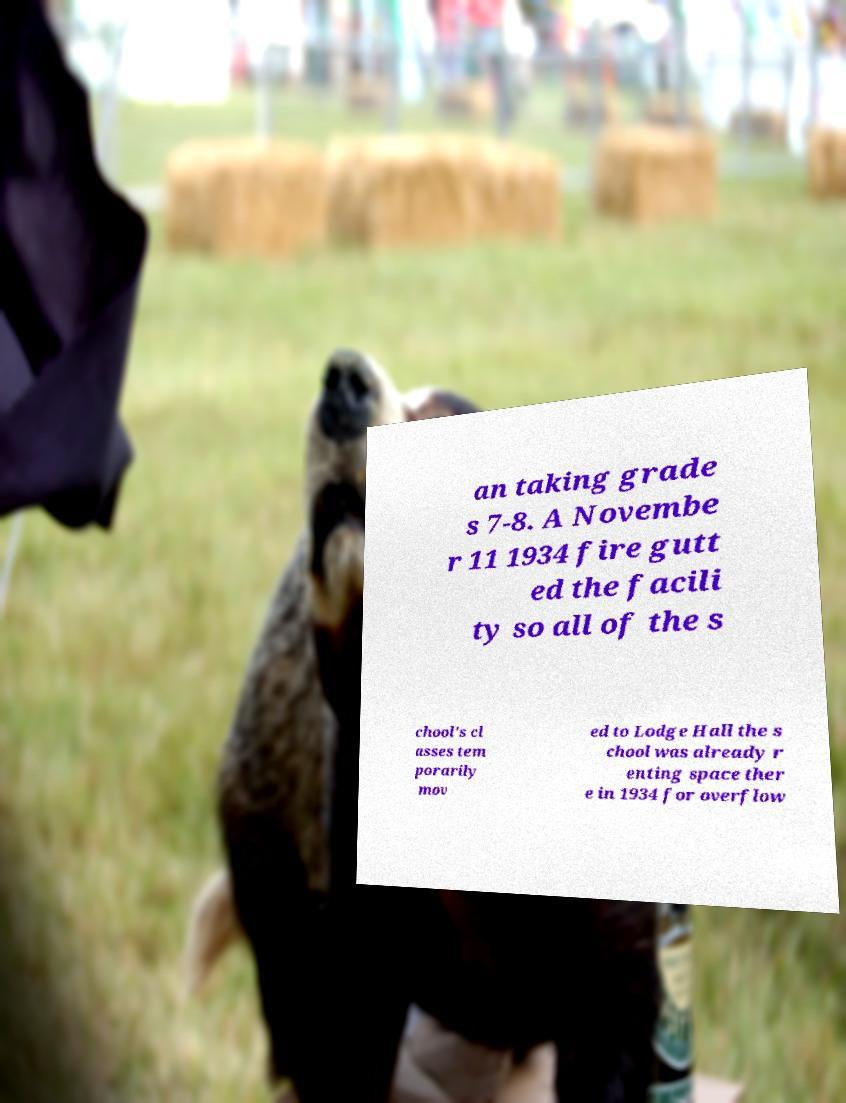Can you accurately transcribe the text from the provided image for me? an taking grade s 7-8. A Novembe r 11 1934 fire gutt ed the facili ty so all of the s chool's cl asses tem porarily mov ed to Lodge Hall the s chool was already r enting space ther e in 1934 for overflow 